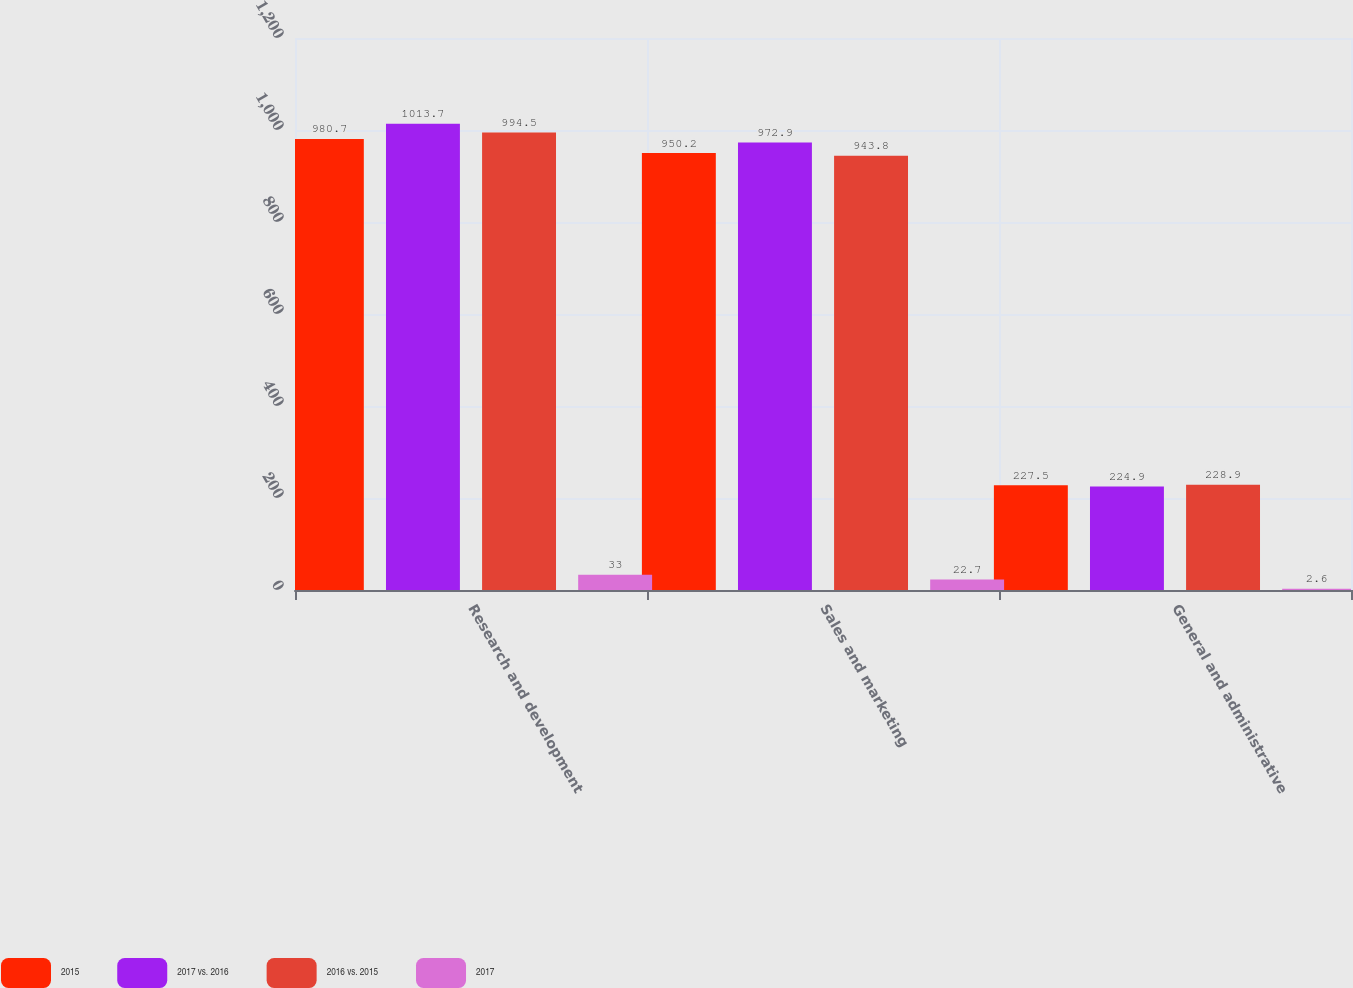Convert chart to OTSL. <chart><loc_0><loc_0><loc_500><loc_500><stacked_bar_chart><ecel><fcel>Research and development<fcel>Sales and marketing<fcel>General and administrative<nl><fcel>2015<fcel>980.7<fcel>950.2<fcel>227.5<nl><fcel>2017 vs. 2016<fcel>1013.7<fcel>972.9<fcel>224.9<nl><fcel>2016 vs. 2015<fcel>994.5<fcel>943.8<fcel>228.9<nl><fcel>2017<fcel>33<fcel>22.7<fcel>2.6<nl></chart> 